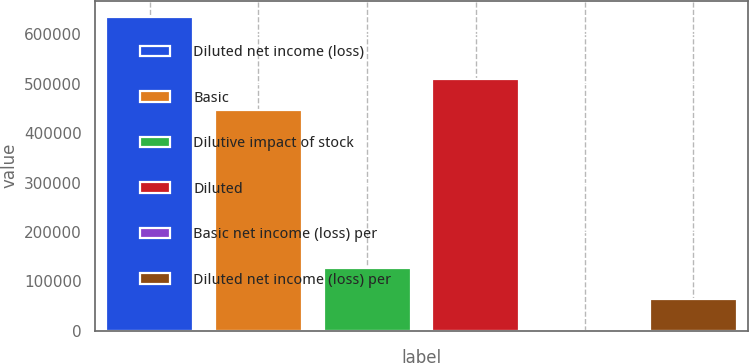Convert chart. <chart><loc_0><loc_0><loc_500><loc_500><bar_chart><fcel>Diluted net income (loss)<fcel>Basic<fcel>Dilutive impact of stock<fcel>Diluted<fcel>Basic net income (loss) per<fcel>Diluted net income (loss) per<nl><fcel>635935<fcel>446874<fcel>127188<fcel>510467<fcel>1.42<fcel>63594.8<nl></chart> 